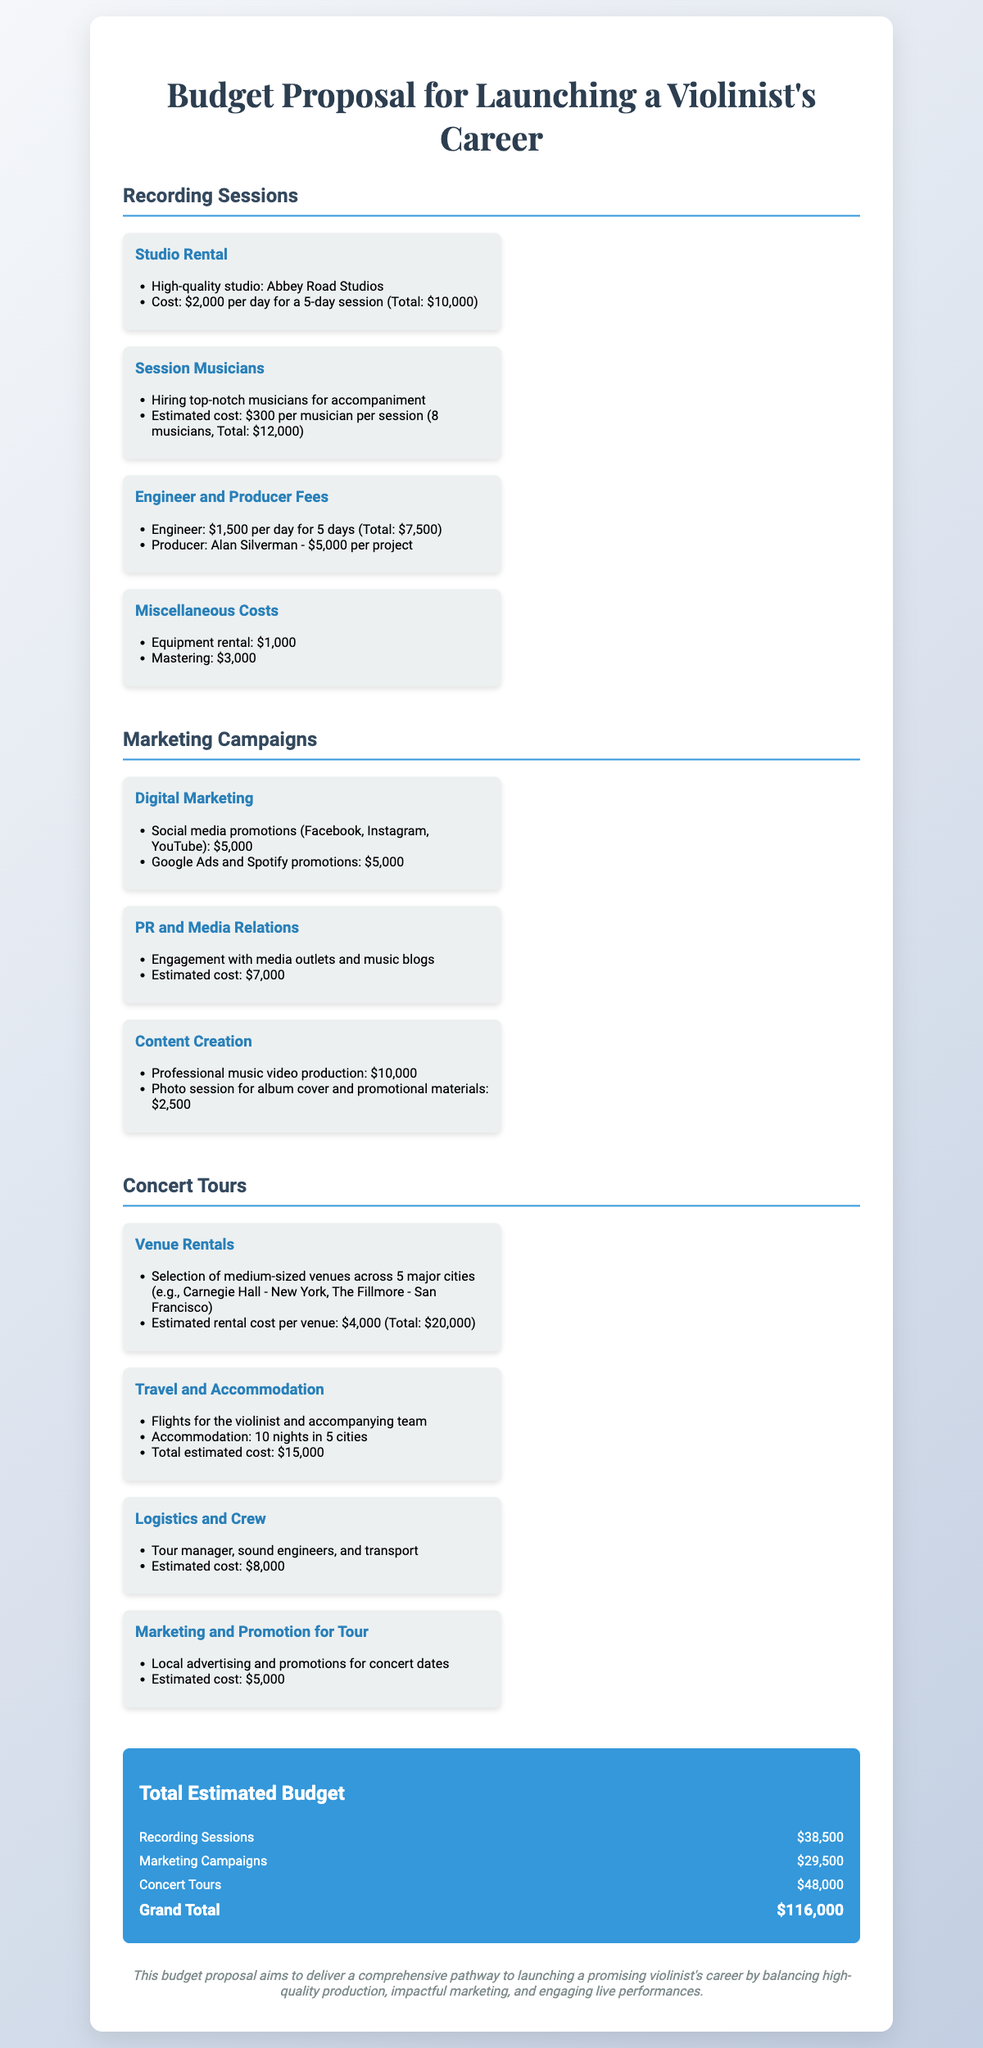what is the studio rental cost per day? The cost for a high-quality studio, Abbey Road Studios, is mentioned as $2,000 per day.
Answer: $2,000 how many session musicians are hired? The document states that 8 musicians are to be hired for accompaniment.
Answer: 8 musicians what is the total estimated cost for digital marketing? The digital marketing costs are listed as $5,000 for social media promotions and another $5,000 for Google Ads and Spotify promotions, totaling $10,000.
Answer: $10,000 which city is Carnegie Hall located in? Carnegie Hall is mentioned as a venue in the context of the concert tour and is located in New York.
Answer: New York what is the grand total estimated budget? The grand total is calculated as the sum of all sections within the budget proposal, totaling $116,000.
Answer: $116,000 how much is allocated for content creation? The cost for content creation is listed as $10,000 for music video production and $2,500 for a photo session, totaling $12,500.
Answer: $12,500 what is the estimated cost for travel and accommodation? The document specifies that the estimated cost for travel and accommodation during the concert tour is $15,000.
Answer: $15,000 who is the producer specified in the budget? Alan Silverman is mentioned as the producer for the project in the budget.
Answer: Alan Silverman what is the total estimated budget for concert tours? The total estimated budget for concert tours is provided as $48,000.
Answer: $48,000 